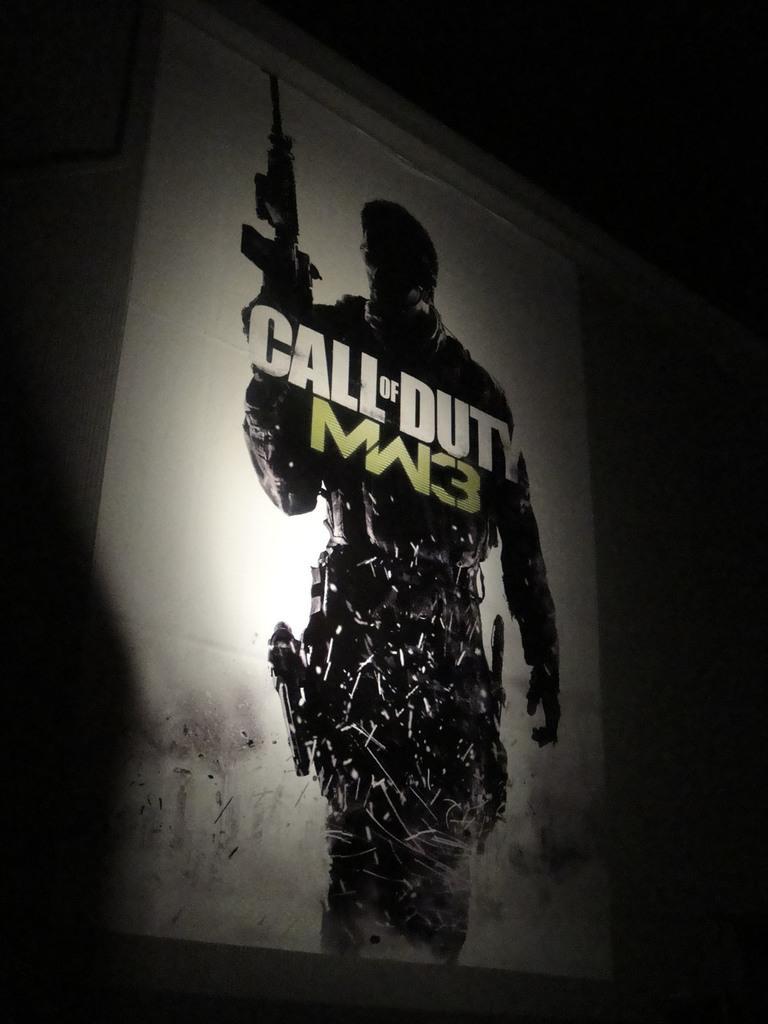Please provide a concise description of this image. In the center of the image we can see poster on the wall. In the poster we can see person holding gun. 